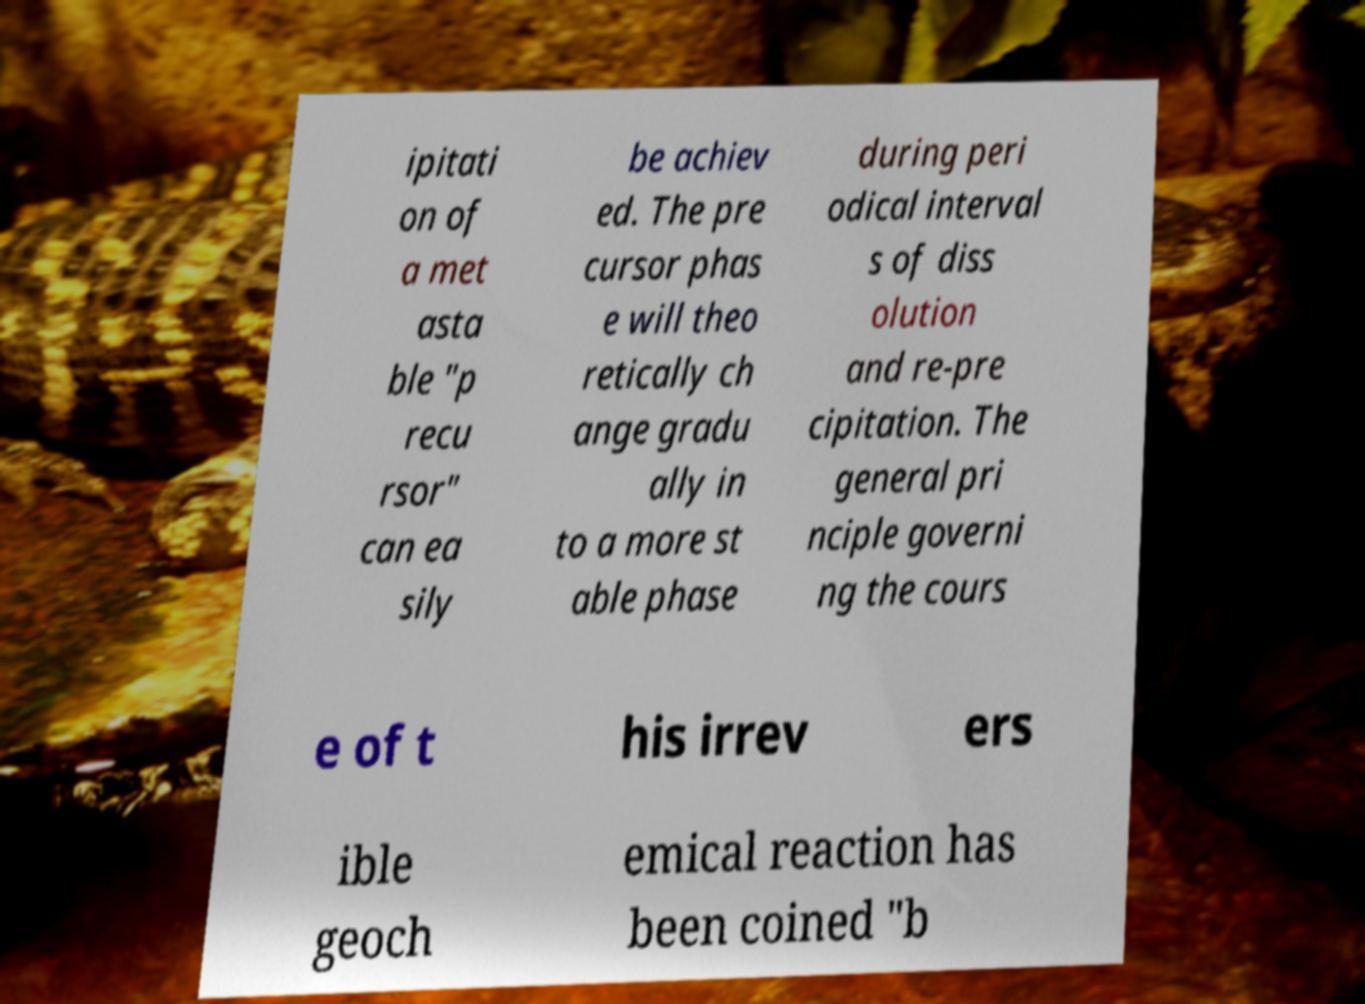Please read and relay the text visible in this image. What does it say? ipitati on of a met asta ble "p recu rsor" can ea sily be achiev ed. The pre cursor phas e will theo retically ch ange gradu ally in to a more st able phase during peri odical interval s of diss olution and re-pre cipitation. The general pri nciple governi ng the cours e of t his irrev ers ible geoch emical reaction has been coined "b 